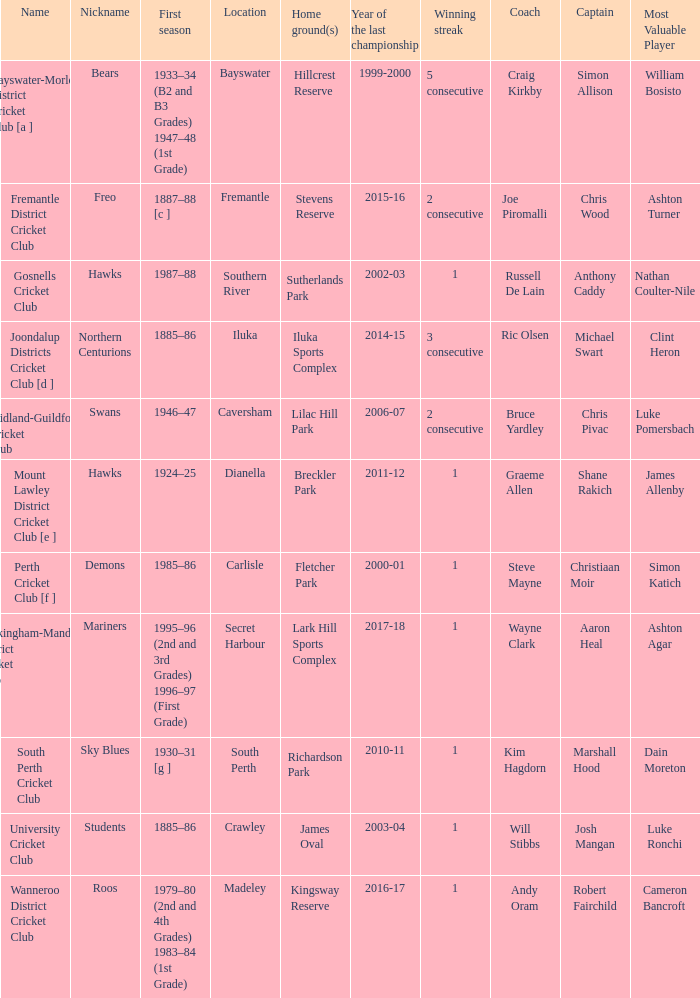With the nickname the swans, what is the home ground? Lilac Hill Park. 